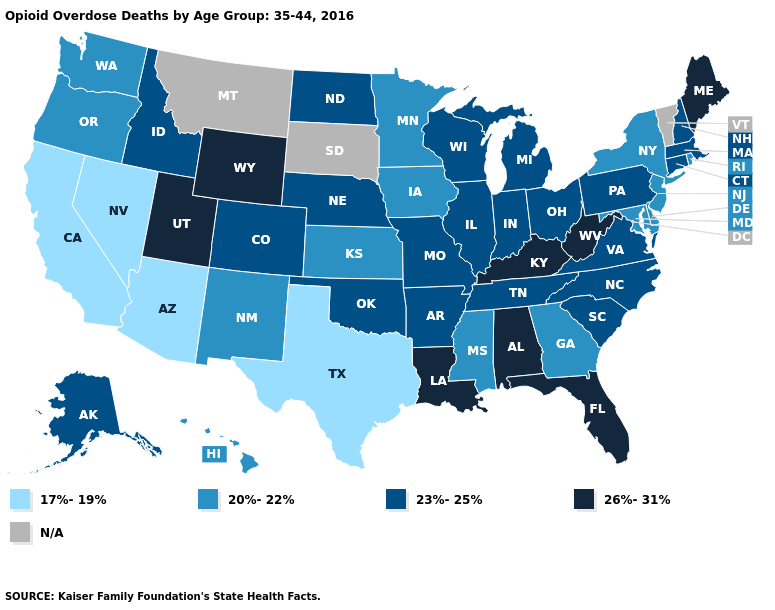Name the states that have a value in the range 20%-22%?
Answer briefly. Delaware, Georgia, Hawaii, Iowa, Kansas, Maryland, Minnesota, Mississippi, New Jersey, New Mexico, New York, Oregon, Rhode Island, Washington. Name the states that have a value in the range 23%-25%?
Give a very brief answer. Alaska, Arkansas, Colorado, Connecticut, Idaho, Illinois, Indiana, Massachusetts, Michigan, Missouri, Nebraska, New Hampshire, North Carolina, North Dakota, Ohio, Oklahoma, Pennsylvania, South Carolina, Tennessee, Virginia, Wisconsin. Does the first symbol in the legend represent the smallest category?
Give a very brief answer. Yes. What is the highest value in the USA?
Concise answer only. 26%-31%. What is the highest value in the USA?
Concise answer only. 26%-31%. Name the states that have a value in the range 23%-25%?
Be succinct. Alaska, Arkansas, Colorado, Connecticut, Idaho, Illinois, Indiana, Massachusetts, Michigan, Missouri, Nebraska, New Hampshire, North Carolina, North Dakota, Ohio, Oklahoma, Pennsylvania, South Carolina, Tennessee, Virginia, Wisconsin. What is the value of South Dakota?
Quick response, please. N/A. What is the value of West Virginia?
Be succinct. 26%-31%. Name the states that have a value in the range 20%-22%?
Short answer required. Delaware, Georgia, Hawaii, Iowa, Kansas, Maryland, Minnesota, Mississippi, New Jersey, New Mexico, New York, Oregon, Rhode Island, Washington. Does Louisiana have the highest value in the USA?
Give a very brief answer. Yes. What is the value of Wyoming?
Short answer required. 26%-31%. Which states have the lowest value in the USA?
Write a very short answer. Arizona, California, Nevada, Texas. What is the highest value in the West ?
Give a very brief answer. 26%-31%. What is the highest value in the MidWest ?
Answer briefly. 23%-25%. How many symbols are there in the legend?
Quick response, please. 5. 